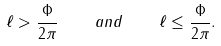Convert formula to latex. <formula><loc_0><loc_0><loc_500><loc_500>\ell > \frac { \Phi } { 2 \pi } \quad a n d \quad \ell \leq \frac { \Phi } { 2 \pi } .</formula> 